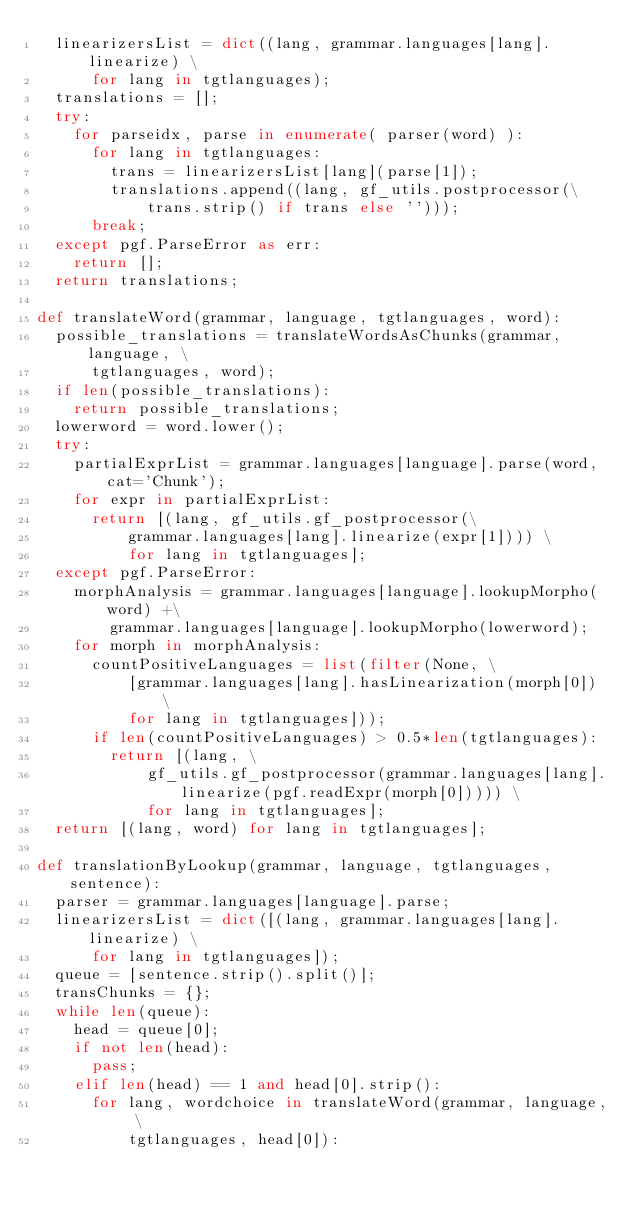<code> <loc_0><loc_0><loc_500><loc_500><_Python_>  linearizersList = dict((lang, grammar.languages[lang].linearize) \
      for lang in tgtlanguages);
  translations = [];
  try:
    for parseidx, parse in enumerate( parser(word) ):
      for lang in tgtlanguages:
        trans = linearizersList[lang](parse[1]);
        translations.append((lang, gf_utils.postprocessor(\
            trans.strip() if trans else '')));
      break;
  except pgf.ParseError as err:
    return [];
  return translations;

def translateWord(grammar, language, tgtlanguages, word):
  possible_translations = translateWordsAsChunks(grammar, language, \
      tgtlanguages, word);
  if len(possible_translations):
    return possible_translations;
  lowerword = word.lower();
  try:
    partialExprList = grammar.languages[language].parse(word, cat='Chunk');
    for expr in partialExprList:
      return [(lang, gf_utils.gf_postprocessor(\
          grammar.languages[lang].linearize(expr[1]))) \
          for lang in tgtlanguages];
  except pgf.ParseError:
    morphAnalysis = grammar.languages[language].lookupMorpho(word) +\
        grammar.languages[language].lookupMorpho(lowerword);
    for morph in morphAnalysis:
      countPositiveLanguages = list(filter(None, \
          [grammar.languages[lang].hasLinearization(morph[0]) \
          for lang in tgtlanguages]));
      if len(countPositiveLanguages) > 0.5*len(tgtlanguages):
        return [(lang, \
            gf_utils.gf_postprocessor(grammar.languages[lang].linearize(pgf.readExpr(morph[0])))) \
            for lang in tgtlanguages];
  return [(lang, word) for lang in tgtlanguages];

def translationByLookup(grammar, language, tgtlanguages, sentence):
  parser = grammar.languages[language].parse;
  linearizersList = dict([(lang, grammar.languages[lang].linearize) \
      for lang in tgtlanguages]);
  queue = [sentence.strip().split()];
  transChunks = {};
  while len(queue):
    head = queue[0];
    if not len(head):
      pass;
    elif len(head) == 1 and head[0].strip():
      for lang, wordchoice in translateWord(grammar, language, \
          tgtlanguages, head[0]):</code> 